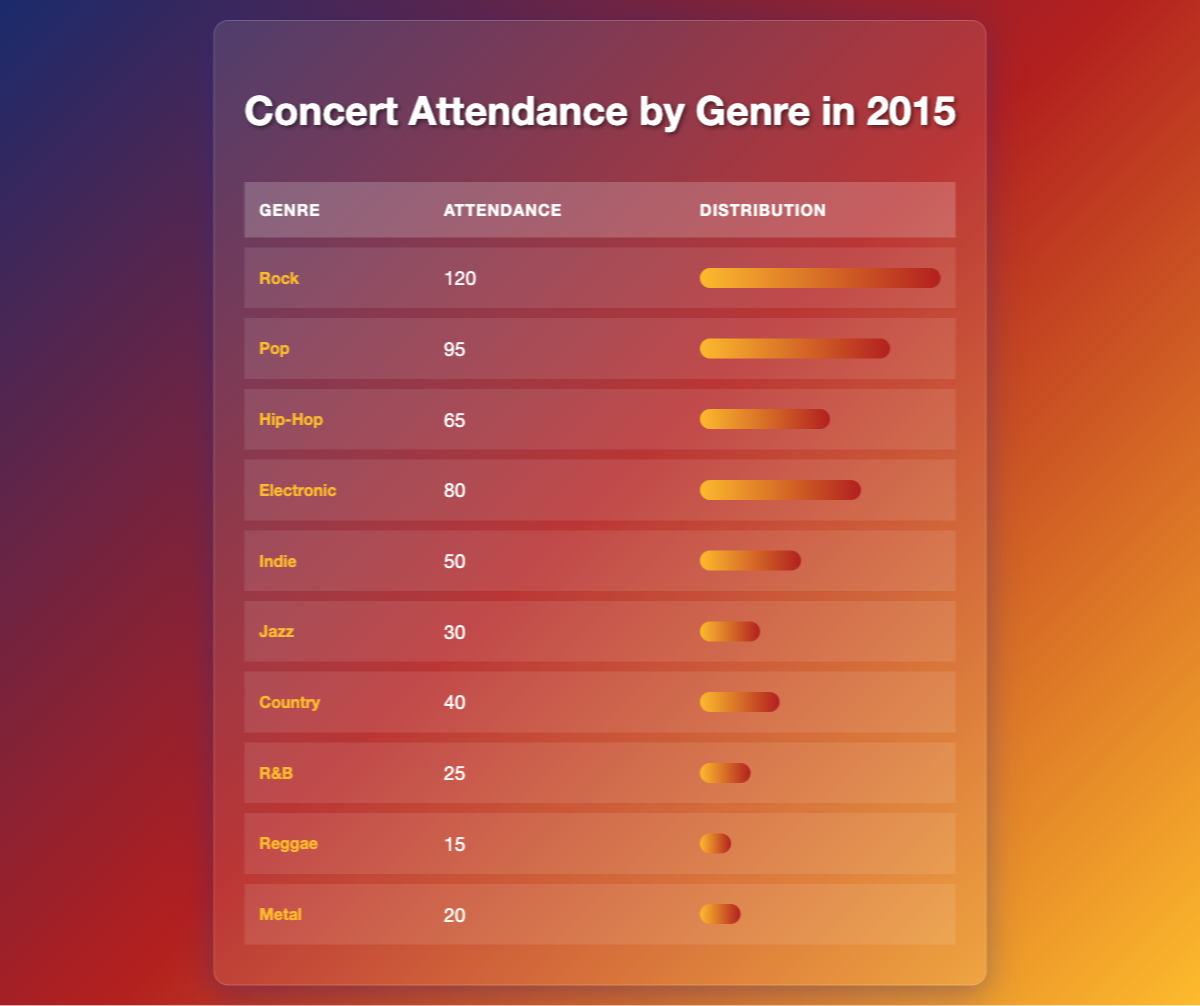What genre had the highest concert attendance in 2015? From the table, we can see that the 'Rock' genre had the highest attendance with a value of 120.
Answer: Rock How many people attended concerts for the Pop genre in 2015? The table shows that the attendance for the Pop genre was 95.
Answer: 95 Which genre had more attendance, Jazz or Country? The attendance for Jazz is 30, while the attendance for Country is 40. Since 40 is greater than 30, Country had more attendance.
Answer: Country What is the total concert attendance across all genres in 2015? To find the total attendance, we add the values for each genre: 120 + 95 + 65 + 80 + 50 + 30 + 40 + 25 + 15 + 20 = 510.
Answer: 510 Is it true that more people attended Hip-Hop concerts than Electronic concerts? The attendance for Hip-Hop is 65 and for Electronic is 80. Since 65 is less than 80, the statement is false.
Answer: No What percentage of the total attendance did Rock concerts account for? The total attendance was 510. To find the percentage for Rock, we calculate (120 / 510) * 100, which equals approximately 23.53%.
Answer: 23.53% What is the difference in attendance between the Indie and R&B genres? The attendance for Indie is 50, and for R&B, it is 25. The difference is calculated as 50 - 25 = 25.
Answer: 25 Which genres had an attendance of less than 50 in 2015? By examining the table, we see that these genres are Indie (50), Jazz (30), R&B (25), Reggae (15), and Metal (20). So, Jazz, R&B, Reggae, and Metal have attendance values less than 50.
Answer: Jazz, R&B, Reggae, Metal What is the average attendance of the top three genres? The top three genres by attendance are Rock (120), Pop (95), and Electronic (80). The average attendance is calculated as (120 + 95 + 80) / 3 = 98.33.
Answer: 98.33 